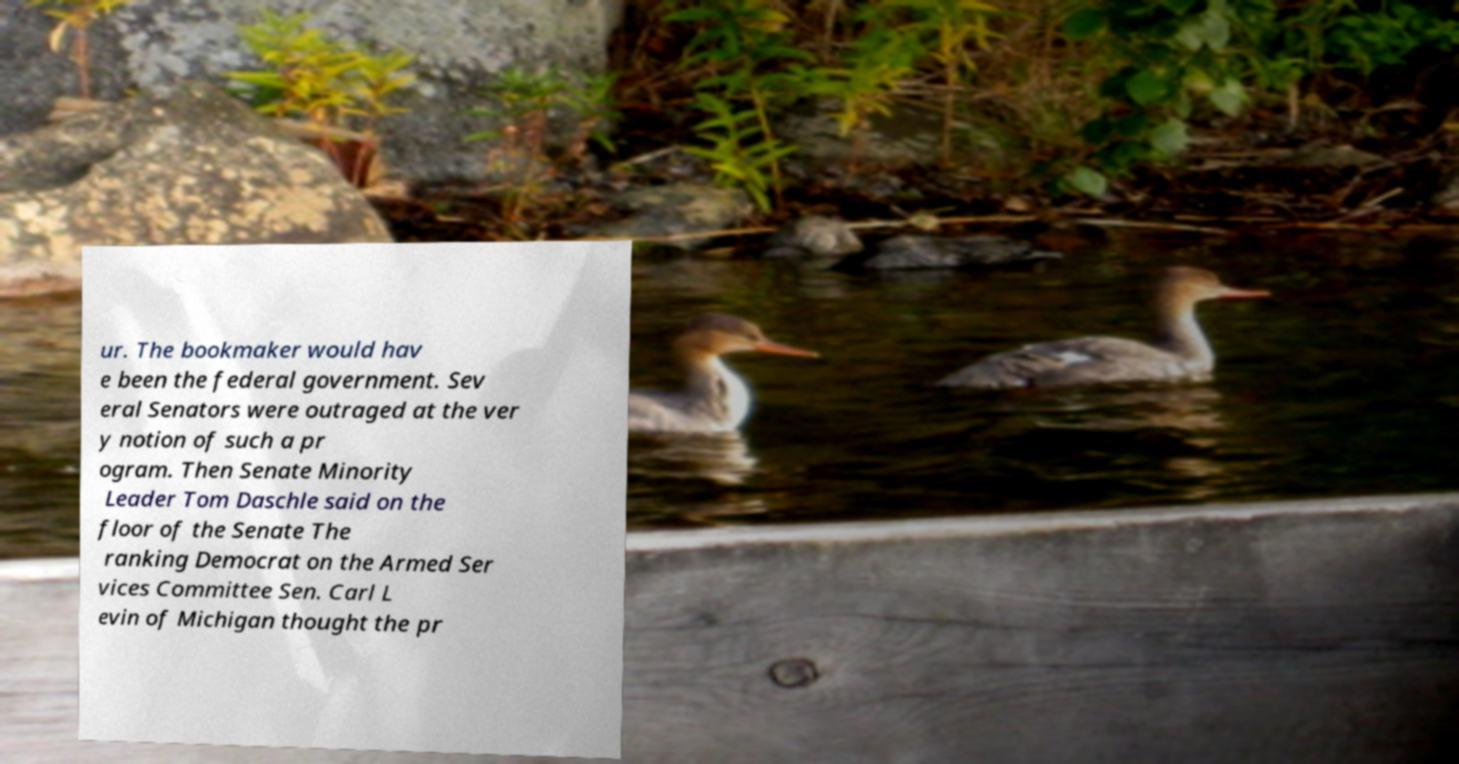Please identify and transcribe the text found in this image. ur. The bookmaker would hav e been the federal government. Sev eral Senators were outraged at the ver y notion of such a pr ogram. Then Senate Minority Leader Tom Daschle said on the floor of the Senate The ranking Democrat on the Armed Ser vices Committee Sen. Carl L evin of Michigan thought the pr 